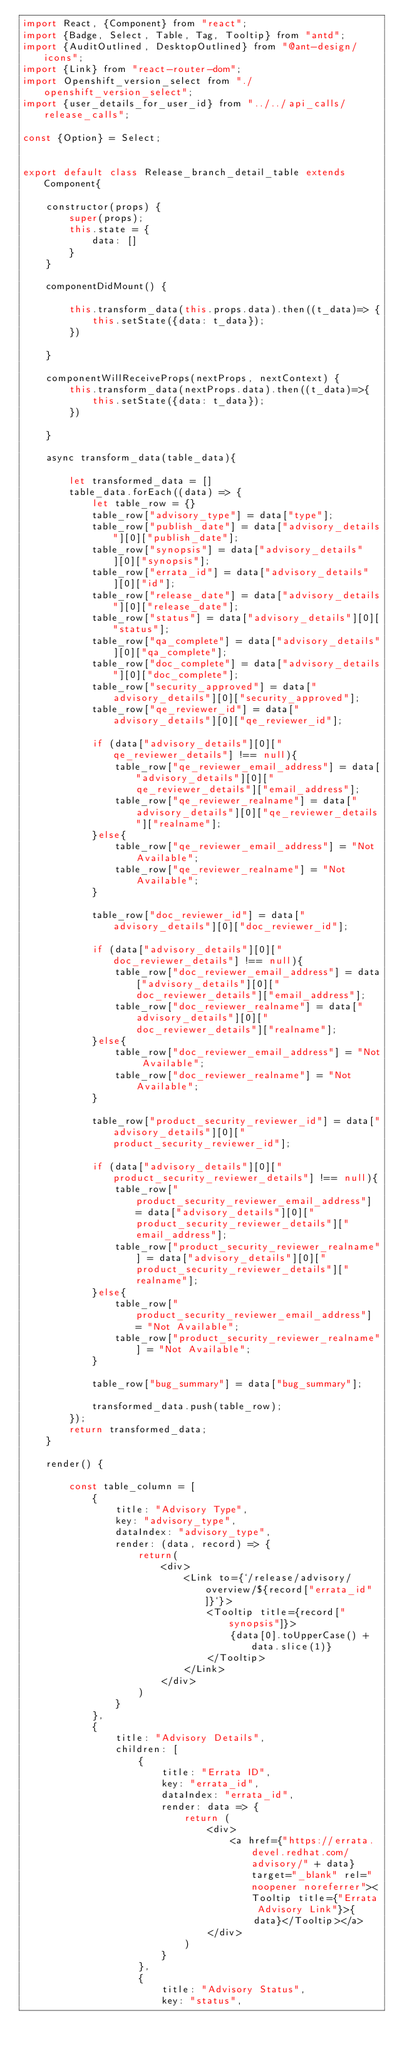Convert code to text. <code><loc_0><loc_0><loc_500><loc_500><_JavaScript_>import React, {Component} from "react";
import {Badge, Select, Table, Tag, Tooltip} from "antd";
import {AuditOutlined, DesktopOutlined} from "@ant-design/icons";
import {Link} from "react-router-dom";
import Openshift_version_select from "./openshift_version_select";
import {user_details_for_user_id} from "../../api_calls/release_calls";

const {Option} = Select;


export default class Release_branch_detail_table extends Component{

    constructor(props) {
        super(props);
        this.state = {
            data: []
        }
    }

    componentDidMount() {

        this.transform_data(this.props.data).then((t_data)=> {
            this.setState({data: t_data});
        })

    }

    componentWillReceiveProps(nextProps, nextContext) {
        this.transform_data(nextProps.data).then((t_data)=>{
            this.setState({data: t_data});
        })

    }

    async transform_data(table_data){

        let transformed_data = []
        table_data.forEach((data) => {
            let table_row = {}
            table_row["advisory_type"] = data["type"];
            table_row["publish_date"] = data["advisory_details"][0]["publish_date"];
            table_row["synopsis"] = data["advisory_details"][0]["synopsis"];
            table_row["errata_id"] = data["advisory_details"][0]["id"];
            table_row["release_date"] = data["advisory_details"][0]["release_date"];
            table_row["status"] = data["advisory_details"][0]["status"];
            table_row["qa_complete"] = data["advisory_details"][0]["qa_complete"];
            table_row["doc_complete"] = data["advisory_details"][0]["doc_complete"];
            table_row["security_approved"] = data["advisory_details"][0]["security_approved"];
            table_row["qe_reviewer_id"] = data["advisory_details"][0]["qe_reviewer_id"];

            if (data["advisory_details"][0]["qe_reviewer_details"] !== null){
                table_row["qe_reviewer_email_address"] = data["advisory_details"][0]["qe_reviewer_details"]["email_address"];
                table_row["qe_reviewer_realname"] = data["advisory_details"][0]["qe_reviewer_details"]["realname"];
            }else{
                table_row["qe_reviewer_email_address"] = "Not Available";
                table_row["qe_reviewer_realname"] = "Not Available";
            }

            table_row["doc_reviewer_id"] = data["advisory_details"][0]["doc_reviewer_id"];

            if (data["advisory_details"][0]["doc_reviewer_details"] !== null){
                table_row["doc_reviewer_email_address"] = data["advisory_details"][0]["doc_reviewer_details"]["email_address"];
                table_row["doc_reviewer_realname"] = data["advisory_details"][0]["doc_reviewer_details"]["realname"];
            }else{
                table_row["doc_reviewer_email_address"] = "Not Available";
                table_row["doc_reviewer_realname"] = "Not Available";
            }

            table_row["product_security_reviewer_id"] = data["advisory_details"][0]["product_security_reviewer_id"];

            if (data["advisory_details"][0]["product_security_reviewer_details"] !== null){
                table_row["product_security_reviewer_email_address"] = data["advisory_details"][0]["product_security_reviewer_details"]["email_address"];
                table_row["product_security_reviewer_realname"] = data["advisory_details"][0]["product_security_reviewer_details"]["realname"];
            }else{
                table_row["product_security_reviewer_email_address"] = "Not Available";
                table_row["product_security_reviewer_realname"] = "Not Available";
            }

            table_row["bug_summary"] = data["bug_summary"];

            transformed_data.push(table_row);
        });
        return transformed_data;
    }

    render() {

        const table_column = [
            {
                title: "Advisory Type",
                key: "advisory_type",
                dataIndex: "advisory_type",
                render: (data, record) => {
                    return(
                        <div>
                            <Link to={`/release/advisory/overview/${record["errata_id"]}`}>
                                <Tooltip title={record["synopsis"]}>
                                    {data[0].toUpperCase() + data.slice(1)}
                                </Tooltip>
                            </Link>
                        </div>
                    )
                }
            },
            {
                title: "Advisory Details",
                children: [
                    {
                        title: "Errata ID",
                        key: "errata_id",
                        dataIndex: "errata_id",
                        render: data => {
                            return (
                                <div>
                                    <a href={"https://errata.devel.redhat.com/advisory/" + data} target="_blank" rel="noopener noreferrer"><Tooltip title={"Errata Advisory Link"}>{
                                        data}</Tooltip></a>
                                </div>
                            )
                        }
                    },
                    {
                        title: "Advisory Status",
                        key: "status",</code> 